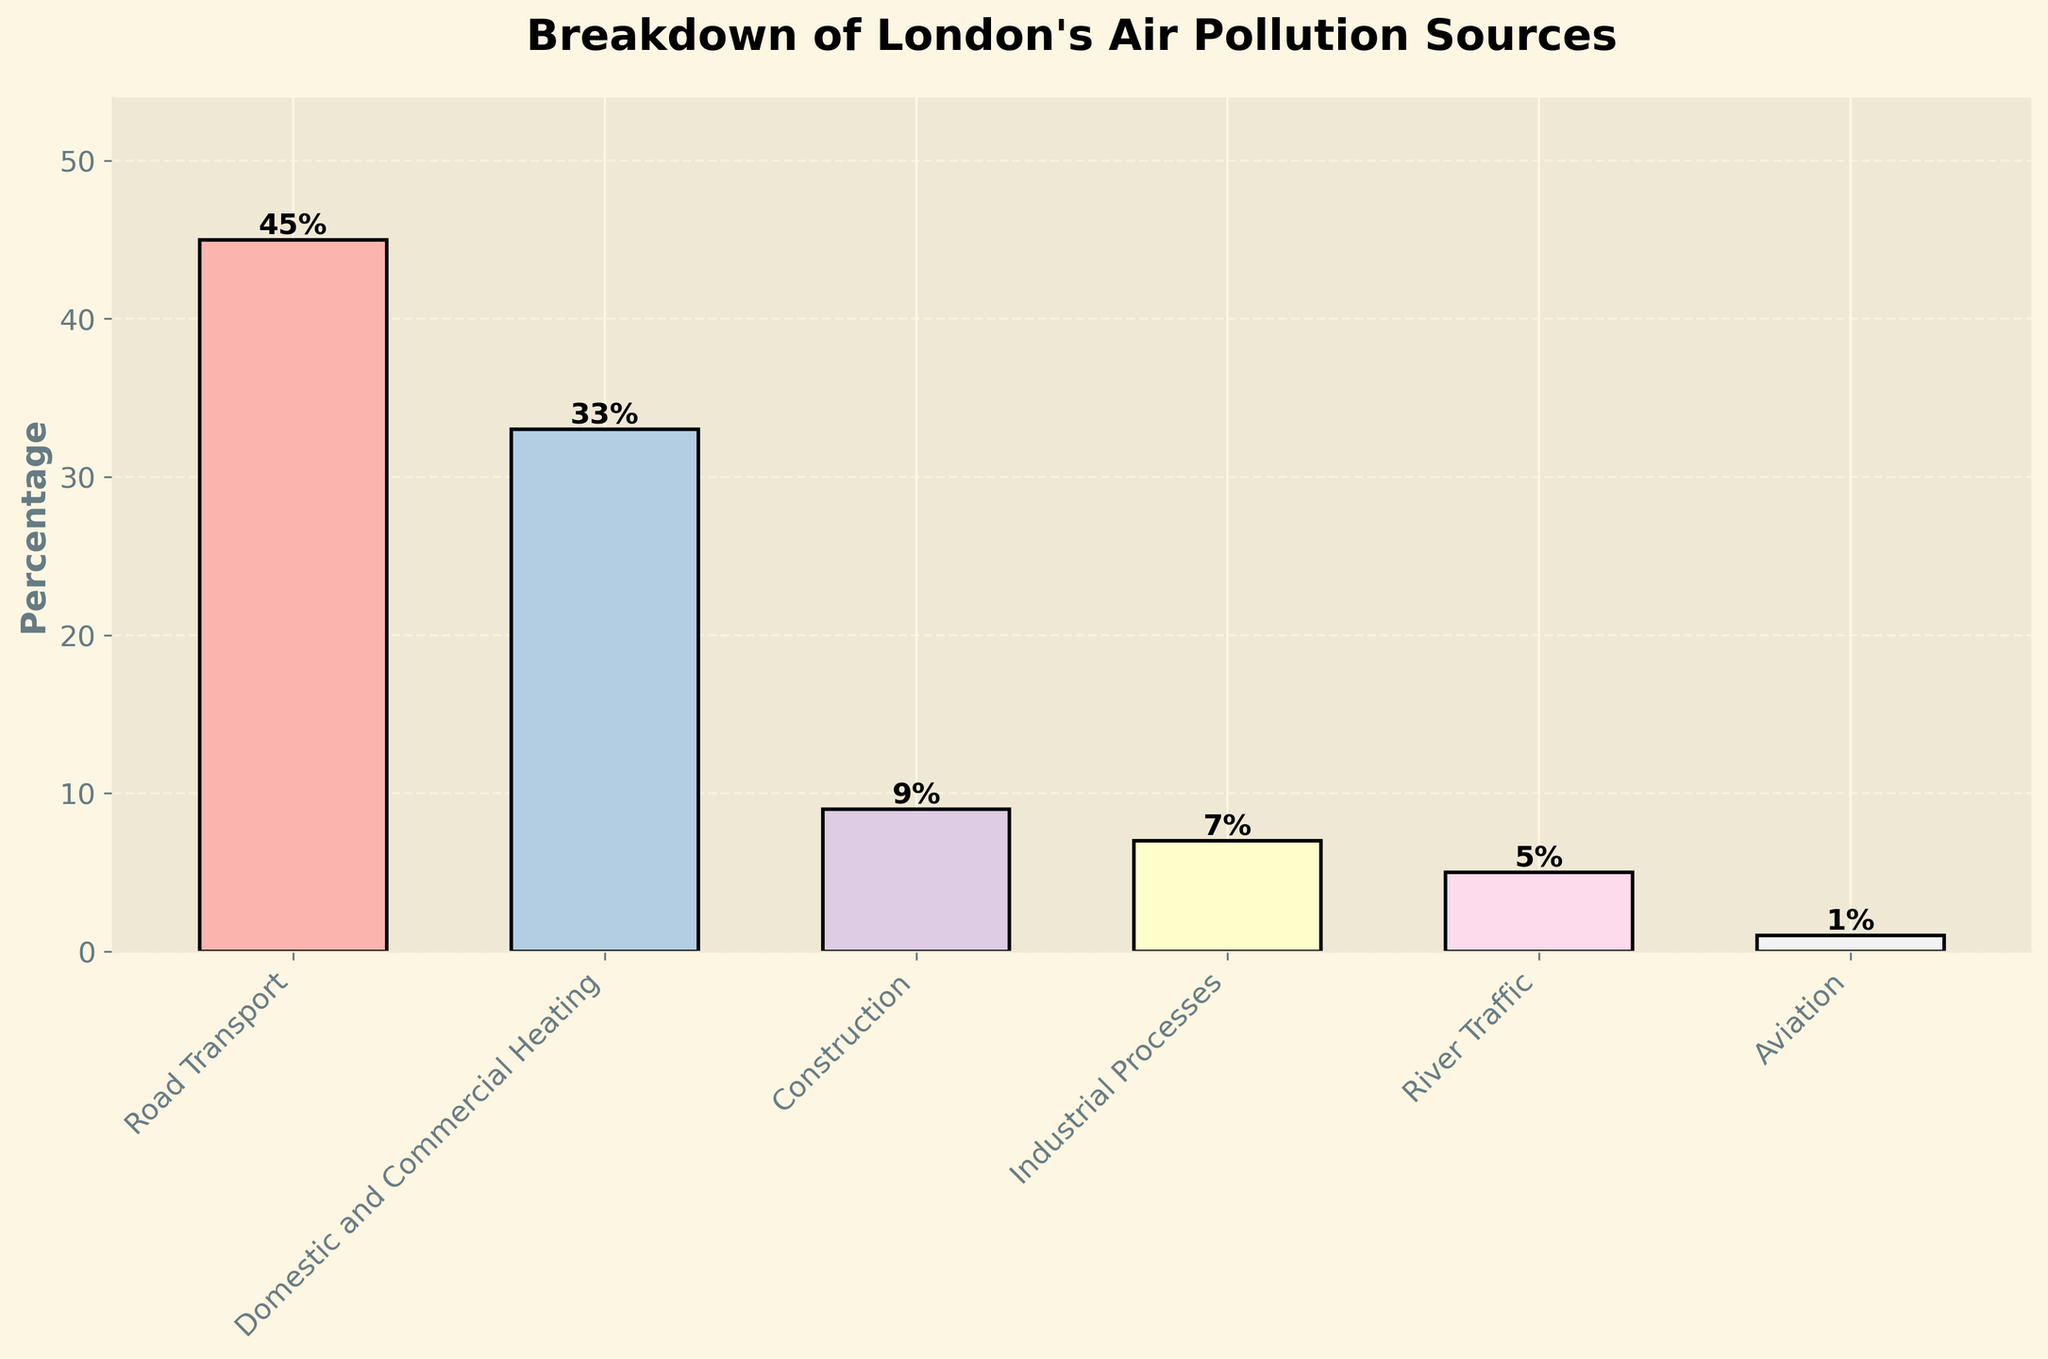What percentage of London's air pollution is due to Road Transport? The bar corresponding to 'Road Transport' shows a height of 45%.
Answer: 45% Which sector contributes the least to London's air pollution? The shortest bar represents the sector with the least contribution, which is 'Aviation' with 1%.
Answer: Aviation By how much does the contribution of 'Domestic and Commercial Heating' exceed that of 'Construction'? The percentage for 'Domestic and Commercial Heating' is 33%, and for 'Construction' it is 9%. The difference is 33% - 9% = 24%.
Answer: 24% What combined percentage of air pollution do 'Construction' and 'Industrial Processes' account for? The percentages for 'Construction' and 'Industrial Processes' are 9% and 7%, respectively. The combined total is 9% + 7% = 16%.
Answer: 16% Which sector has a higher contribution to air pollution, 'River Traffic' or 'Domestic and Commercial Heating'? Comparing the heights of the bars, 'Domestic and Commercial Heating' at 33% is higher than 'River Traffic' at 5%.
Answer: Domestic and Commercial Heating Is the contribution of 'Road Transport' more than double the contribution of 'Domestic and Commercial Heating'? The percentage for 'Road Transport' is 45% and for 'Domestic and Commercial Heating' it is 33%. Checking if 45% > 2 * 33% (which is 66%), we see it is not.
Answer: No Which sector's contribution is closest to one-tenth of the total air pollution from 'Road Transport'? One-tenth of the 'Road Transport' contribution is 4.5%. The sector closest to this value is 'River Traffic' at 5%.
Answer: River Traffic How much do 'Industrial Processes' and 'River Traffic' combined contribute to London's air pollution? The percentages for 'Industrial Processes' and 'River Traffic' are 7% and 5%, respectively. Summing these gives 7% + 5% = 12%.
Answer: 12% How does the height of the 'Aviation' bar compare to the 'Road Transport' bar? The height of the 'Aviation' bar (1%) is much shorter than that of the 'Road Transport' bar (45%).
Answer: Much shorter 